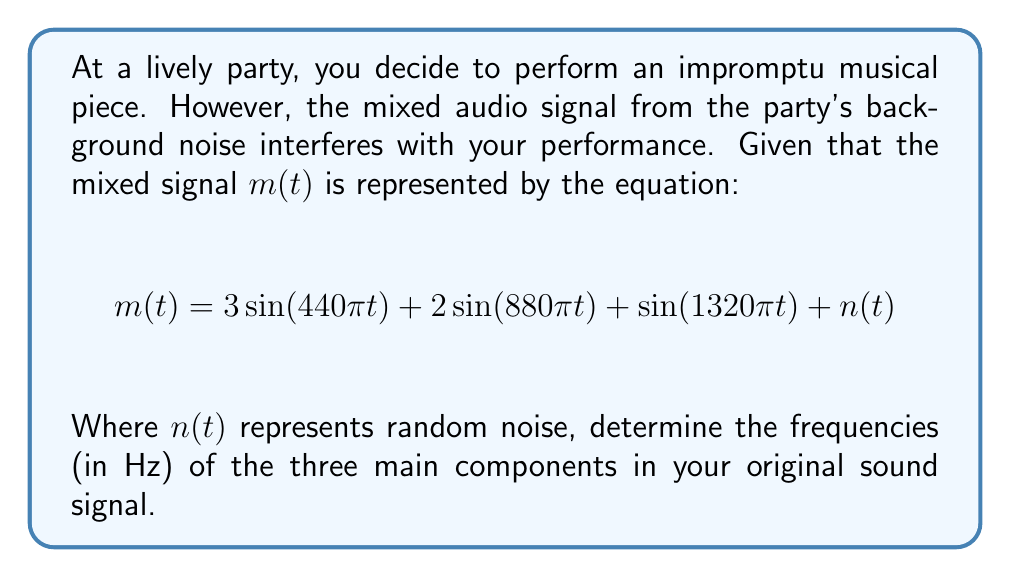Could you help me with this problem? To solve this inverse problem and determine the original sound frequencies, we need to analyze the given mixed signal equation:

1) The general form of a sinusoidal wave is $A\sin(2\pi ft)$, where $f$ is the frequency in Hz.

2) In our equation, we have three sinusoidal terms:
   
   $3\sin(440\pi t)$
   $2\sin(880\pi t)$
   $\sin(1320\pi t)$

3) For each term, we need to equate the argument of sine to $2\pi ft$:

   For the first term: $440\pi t = 2\pi ft$
   For the second term: $880\pi t = 2\pi ft$
   For the third term: $1320\pi t = 2\pi ft$

4) Solving for $f$ in each case:

   First term: $f = 440/2 = 220$ Hz
   Second term: $f = 880/2 = 440$ Hz
   Third term: $f = 1320/2 = 660$ Hz

5) The $n(t)$ term represents random noise and doesn't contribute to the main frequency components.

Therefore, the three main frequency components of your original sound signal are 220 Hz, 440 Hz, and 660 Hz.
Answer: 220 Hz, 440 Hz, 660 Hz 